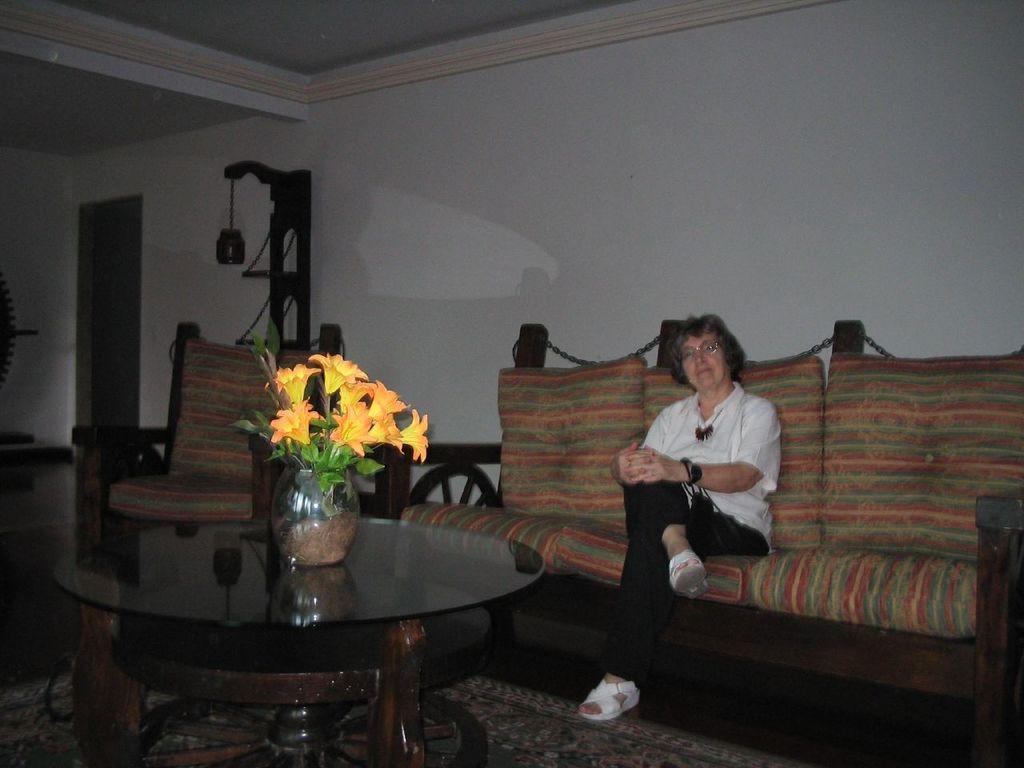Please provide a concise description of this image. In this image we can see a woman sitting on the sofa. We can see flower vase on the table. In the background we can see a wall and chair. 